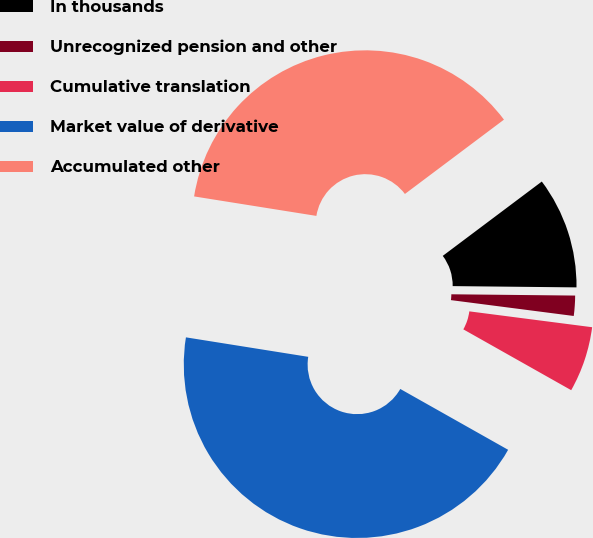Convert chart to OTSL. <chart><loc_0><loc_0><loc_500><loc_500><pie_chart><fcel>In thousands<fcel>Unrecognized pension and other<fcel>Cumulative translation<fcel>Market value of derivative<fcel>Accumulated other<nl><fcel>10.41%<fcel>1.88%<fcel>6.13%<fcel>44.34%<fcel>37.24%<nl></chart> 